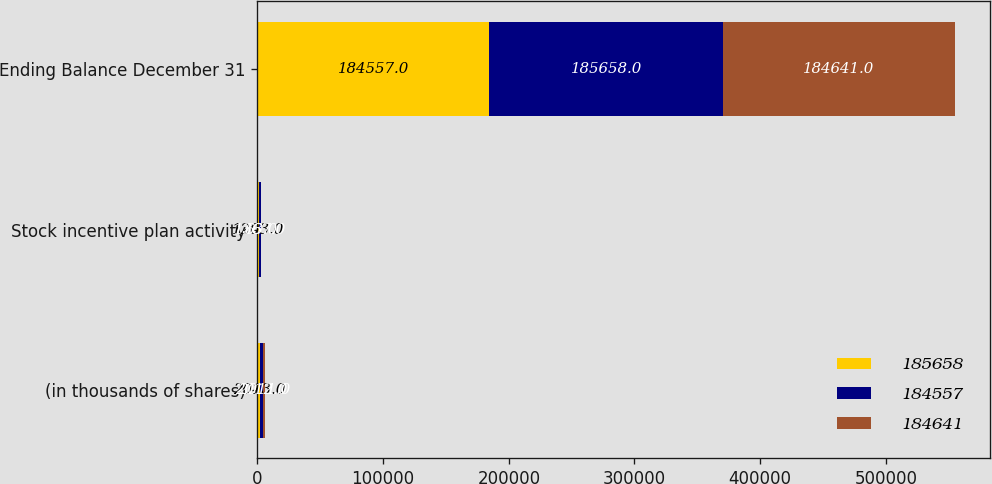Convert chart. <chart><loc_0><loc_0><loc_500><loc_500><stacked_bar_chart><ecel><fcel>(in thousands of shares)<fcel>Stock incentive plan activity<fcel>Ending Balance December 31<nl><fcel>185658<fcel>2013<fcel>1203<fcel>184557<nl><fcel>184557<fcel>2012<fcel>1367<fcel>185658<nl><fcel>184641<fcel>2011<fcel>63<fcel>184641<nl></chart> 